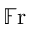<formula> <loc_0><loc_0><loc_500><loc_500>\mathbb { F } r</formula> 